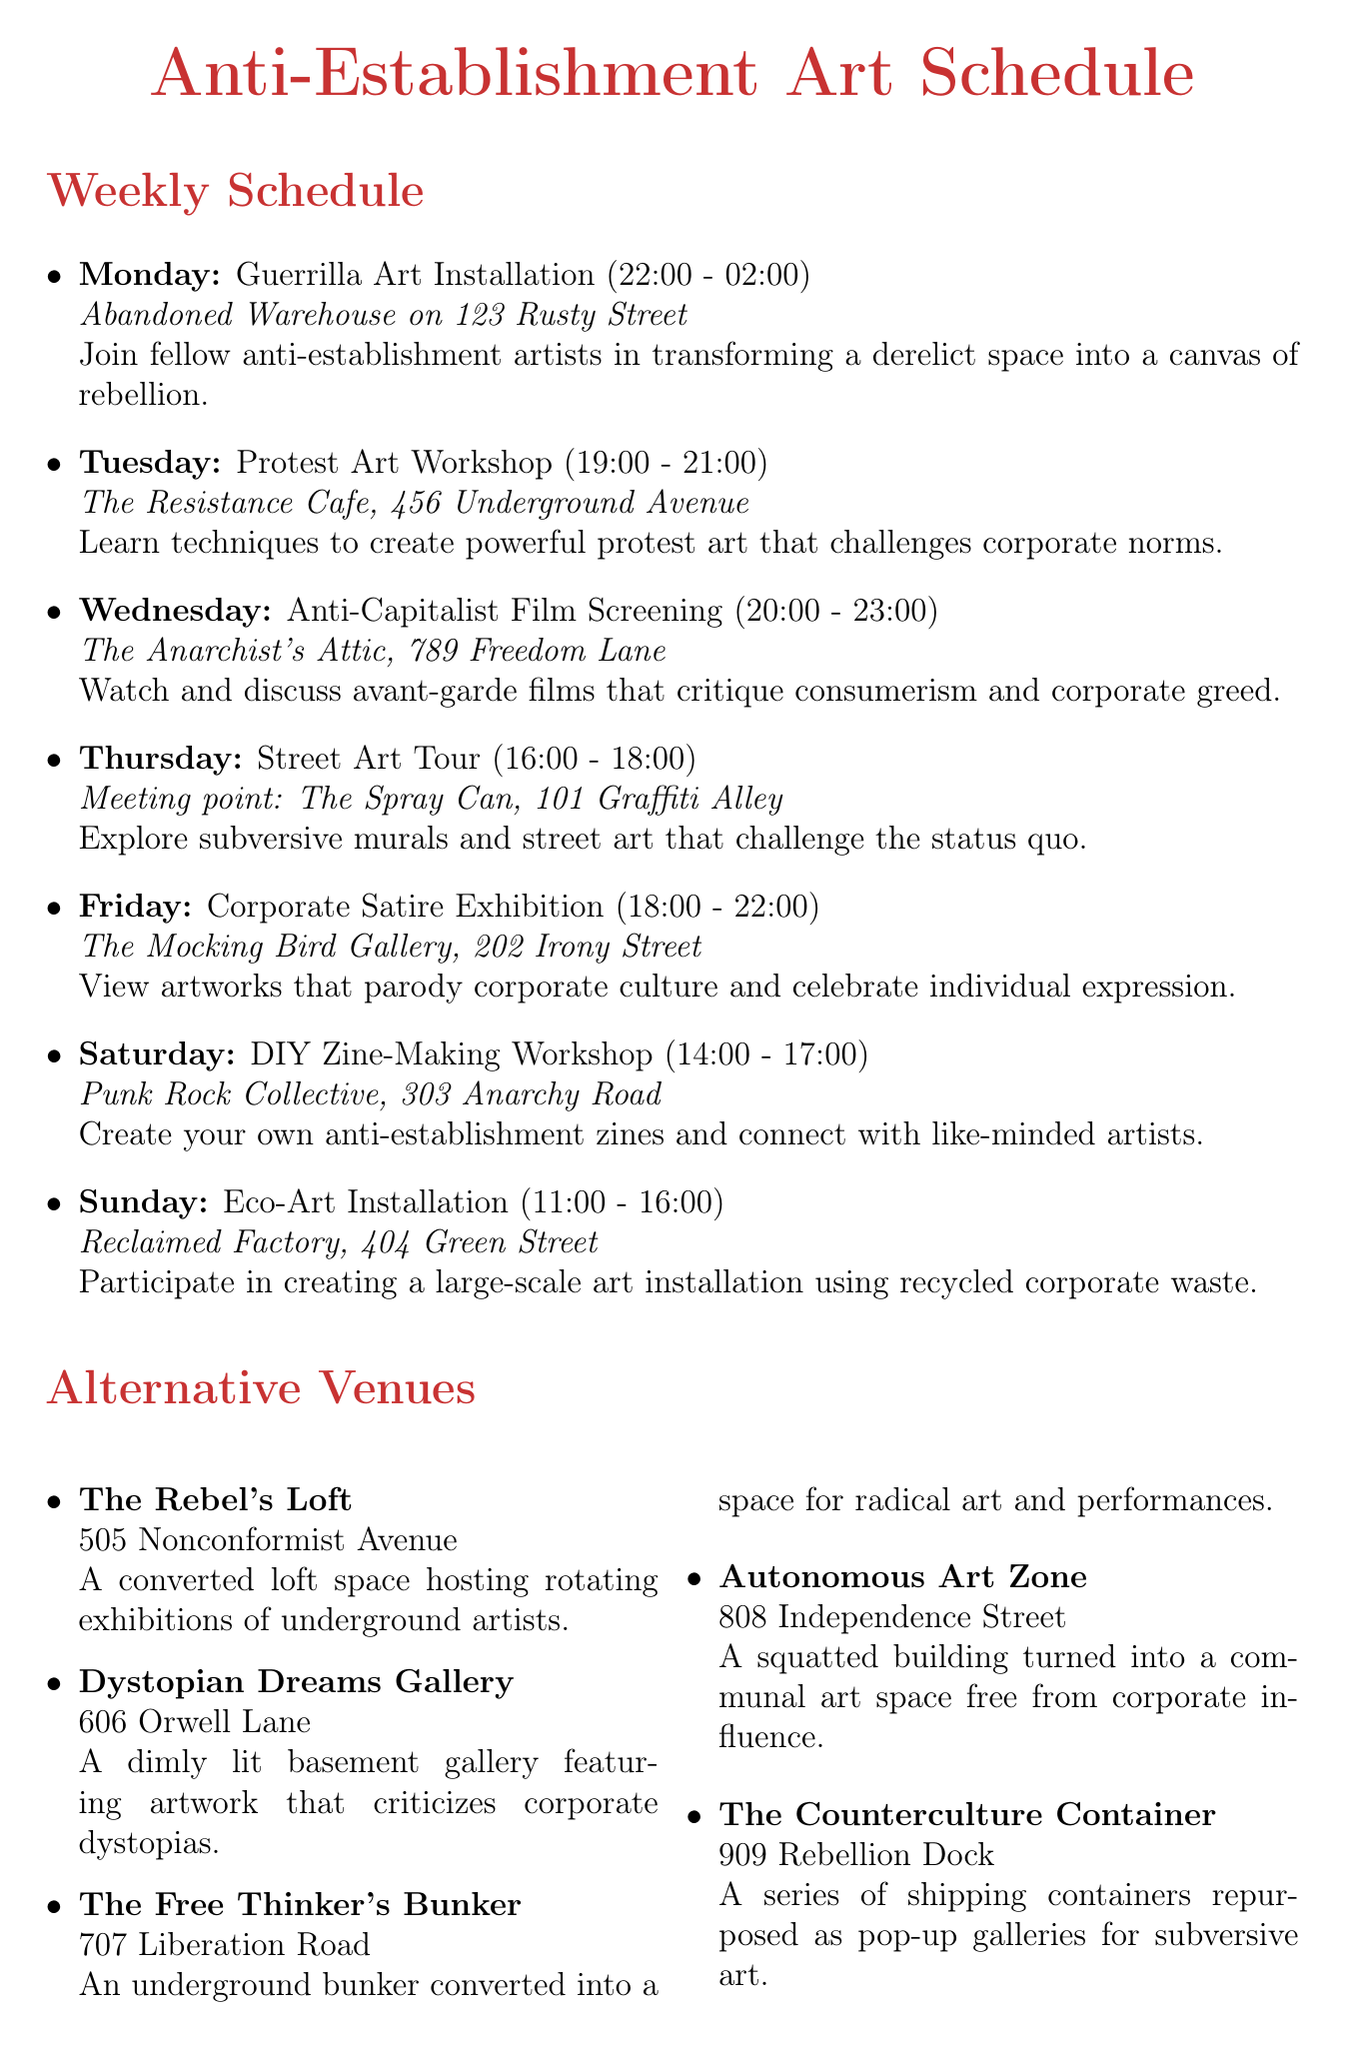What event is scheduled for Wednesday? The document lists "Anti-Capitalist Film Screening" as the event for Wednesday.
Answer: Anti-Capitalist Film Screening Where is the DIY Zine-Making Workshop held? The venue for the DIY Zine-Making Workshop is specified as "Punk Rock Collective, 303 Anarchy Road."
Answer: Punk Rock Collective, 303 Anarchy Road What time does the Eco-Art Installation start? According to the schedule, the Eco-Art Installation begins at 11:00.
Answer: 11:00 Which day features the Corporate Satire Exhibition? The Corporate Satire Exhibition is scheduled for Friday.
Answer: Friday How many alternative venues are listed? The document provides a list of five alternative venues.
Answer: 5 What is the description of The Counterculture Container? The description states that it is "A series of shipping containers repurposed as pop-up galleries for subversive art."
Answer: A series of shipping containers repurposed as pop-up galleries for subversive art When is the Annual Anti-Corporate Art Festival? The date for the Annual Anti-Corporate Art Festival is listed as July 15-17.
Answer: July 15-17 What type of art will be created during Midnight Mural Madness? The event is a "covert operation to create large-scale murals critiquing corporate advertising."
Answer: Murals critiquing corporate advertising Where is the Smash the System Sculpture Symposium held? The venue is specified as "The Anarchist's Foundry, 1010 Revolution Road."
Answer: The Anarchist's Foundry, 1010 Revolution Road 